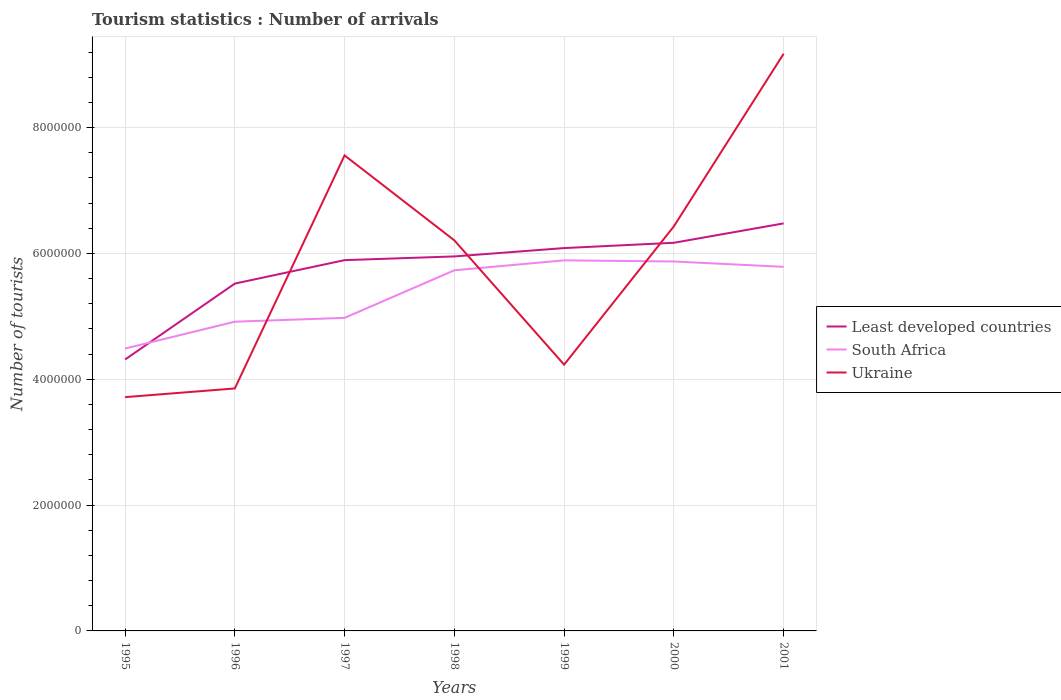How many different coloured lines are there?
Make the answer very short. 3. Is the number of lines equal to the number of legend labels?
Offer a very short reply. Yes. Across all years, what is the maximum number of tourist arrivals in South Africa?
Make the answer very short. 4.49e+06. In which year was the number of tourist arrivals in South Africa maximum?
Give a very brief answer. 1995. What is the total number of tourist arrivals in Ukraine in the graph?
Make the answer very short. 1.13e+06. What is the difference between the highest and the second highest number of tourist arrivals in South Africa?
Give a very brief answer. 1.40e+06. What is the difference between the highest and the lowest number of tourist arrivals in South Africa?
Offer a terse response. 4. How many lines are there?
Offer a terse response. 3. Are the values on the major ticks of Y-axis written in scientific E-notation?
Your answer should be compact. No. Does the graph contain grids?
Your response must be concise. Yes. How many legend labels are there?
Provide a short and direct response. 3. How are the legend labels stacked?
Your answer should be compact. Vertical. What is the title of the graph?
Your response must be concise. Tourism statistics : Number of arrivals. What is the label or title of the Y-axis?
Your answer should be very brief. Number of tourists. What is the Number of tourists in Least developed countries in 1995?
Ensure brevity in your answer.  4.31e+06. What is the Number of tourists in South Africa in 1995?
Your answer should be very brief. 4.49e+06. What is the Number of tourists in Ukraine in 1995?
Your response must be concise. 3.72e+06. What is the Number of tourists in Least developed countries in 1996?
Offer a terse response. 5.52e+06. What is the Number of tourists in South Africa in 1996?
Provide a short and direct response. 4.92e+06. What is the Number of tourists in Ukraine in 1996?
Offer a very short reply. 3.85e+06. What is the Number of tourists of Least developed countries in 1997?
Keep it short and to the point. 5.89e+06. What is the Number of tourists in South Africa in 1997?
Make the answer very short. 4.98e+06. What is the Number of tourists in Ukraine in 1997?
Your response must be concise. 7.56e+06. What is the Number of tourists of Least developed countries in 1998?
Your answer should be compact. 5.95e+06. What is the Number of tourists in South Africa in 1998?
Keep it short and to the point. 5.73e+06. What is the Number of tourists in Ukraine in 1998?
Keep it short and to the point. 6.21e+06. What is the Number of tourists of Least developed countries in 1999?
Provide a succinct answer. 6.09e+06. What is the Number of tourists in South Africa in 1999?
Make the answer very short. 5.89e+06. What is the Number of tourists in Ukraine in 1999?
Give a very brief answer. 4.23e+06. What is the Number of tourists in Least developed countries in 2000?
Provide a succinct answer. 6.17e+06. What is the Number of tourists of South Africa in 2000?
Keep it short and to the point. 5.87e+06. What is the Number of tourists of Ukraine in 2000?
Offer a terse response. 6.43e+06. What is the Number of tourists in Least developed countries in 2001?
Your response must be concise. 6.48e+06. What is the Number of tourists of South Africa in 2001?
Keep it short and to the point. 5.79e+06. What is the Number of tourists in Ukraine in 2001?
Offer a terse response. 9.17e+06. Across all years, what is the maximum Number of tourists of Least developed countries?
Ensure brevity in your answer.  6.48e+06. Across all years, what is the maximum Number of tourists of South Africa?
Provide a short and direct response. 5.89e+06. Across all years, what is the maximum Number of tourists in Ukraine?
Your response must be concise. 9.17e+06. Across all years, what is the minimum Number of tourists in Least developed countries?
Ensure brevity in your answer.  4.31e+06. Across all years, what is the minimum Number of tourists in South Africa?
Offer a terse response. 4.49e+06. Across all years, what is the minimum Number of tourists of Ukraine?
Keep it short and to the point. 3.72e+06. What is the total Number of tourists of Least developed countries in the graph?
Provide a succinct answer. 4.04e+07. What is the total Number of tourists of South Africa in the graph?
Your answer should be compact. 3.77e+07. What is the total Number of tourists of Ukraine in the graph?
Your answer should be very brief. 4.12e+07. What is the difference between the Number of tourists in Least developed countries in 1995 and that in 1996?
Your answer should be very brief. -1.21e+06. What is the difference between the Number of tourists of South Africa in 1995 and that in 1996?
Give a very brief answer. -4.27e+05. What is the difference between the Number of tourists in Ukraine in 1995 and that in 1996?
Provide a short and direct response. -1.38e+05. What is the difference between the Number of tourists in Least developed countries in 1995 and that in 1997?
Your response must be concise. -1.58e+06. What is the difference between the Number of tourists in South Africa in 1995 and that in 1997?
Offer a very short reply. -4.88e+05. What is the difference between the Number of tourists of Ukraine in 1995 and that in 1997?
Your answer should be very brief. -3.84e+06. What is the difference between the Number of tourists of Least developed countries in 1995 and that in 1998?
Make the answer very short. -1.64e+06. What is the difference between the Number of tourists in South Africa in 1995 and that in 1998?
Offer a terse response. -1.24e+06. What is the difference between the Number of tourists in Ukraine in 1995 and that in 1998?
Give a very brief answer. -2.49e+06. What is the difference between the Number of tourists in Least developed countries in 1995 and that in 1999?
Your response must be concise. -1.77e+06. What is the difference between the Number of tourists of South Africa in 1995 and that in 1999?
Make the answer very short. -1.40e+06. What is the difference between the Number of tourists in Ukraine in 1995 and that in 1999?
Ensure brevity in your answer.  -5.16e+05. What is the difference between the Number of tourists of Least developed countries in 1995 and that in 2000?
Offer a very short reply. -1.86e+06. What is the difference between the Number of tourists in South Africa in 1995 and that in 2000?
Your answer should be very brief. -1.38e+06. What is the difference between the Number of tourists in Ukraine in 1995 and that in 2000?
Make the answer very short. -2.72e+06. What is the difference between the Number of tourists in Least developed countries in 1995 and that in 2001?
Make the answer very short. -2.16e+06. What is the difference between the Number of tourists in South Africa in 1995 and that in 2001?
Ensure brevity in your answer.  -1.30e+06. What is the difference between the Number of tourists in Ukraine in 1995 and that in 2001?
Offer a terse response. -5.46e+06. What is the difference between the Number of tourists of Least developed countries in 1996 and that in 1997?
Your answer should be very brief. -3.73e+05. What is the difference between the Number of tourists of South Africa in 1996 and that in 1997?
Give a very brief answer. -6.10e+04. What is the difference between the Number of tourists in Ukraine in 1996 and that in 1997?
Your answer should be compact. -3.70e+06. What is the difference between the Number of tourists in Least developed countries in 1996 and that in 1998?
Provide a succinct answer. -4.32e+05. What is the difference between the Number of tourists of South Africa in 1996 and that in 1998?
Offer a terse response. -8.17e+05. What is the difference between the Number of tourists of Ukraine in 1996 and that in 1998?
Make the answer very short. -2.35e+06. What is the difference between the Number of tourists in Least developed countries in 1996 and that in 1999?
Make the answer very short. -5.65e+05. What is the difference between the Number of tourists in South Africa in 1996 and that in 1999?
Keep it short and to the point. -9.75e+05. What is the difference between the Number of tourists of Ukraine in 1996 and that in 1999?
Your answer should be very brief. -3.78e+05. What is the difference between the Number of tourists in Least developed countries in 1996 and that in 2000?
Your answer should be very brief. -6.49e+05. What is the difference between the Number of tourists in South Africa in 1996 and that in 2000?
Offer a terse response. -9.57e+05. What is the difference between the Number of tourists of Ukraine in 1996 and that in 2000?
Your answer should be very brief. -2.58e+06. What is the difference between the Number of tourists in Least developed countries in 1996 and that in 2001?
Make the answer very short. -9.57e+05. What is the difference between the Number of tourists in South Africa in 1996 and that in 2001?
Your answer should be compact. -8.72e+05. What is the difference between the Number of tourists in Ukraine in 1996 and that in 2001?
Offer a very short reply. -5.32e+06. What is the difference between the Number of tourists in Least developed countries in 1997 and that in 1998?
Ensure brevity in your answer.  -5.89e+04. What is the difference between the Number of tourists of South Africa in 1997 and that in 1998?
Offer a terse response. -7.56e+05. What is the difference between the Number of tourists in Ukraine in 1997 and that in 1998?
Provide a short and direct response. 1.35e+06. What is the difference between the Number of tourists of Least developed countries in 1997 and that in 1999?
Provide a short and direct response. -1.92e+05. What is the difference between the Number of tourists in South Africa in 1997 and that in 1999?
Keep it short and to the point. -9.14e+05. What is the difference between the Number of tourists of Ukraine in 1997 and that in 1999?
Offer a very short reply. 3.33e+06. What is the difference between the Number of tourists in Least developed countries in 1997 and that in 2000?
Keep it short and to the point. -2.76e+05. What is the difference between the Number of tourists in South Africa in 1997 and that in 2000?
Provide a short and direct response. -8.96e+05. What is the difference between the Number of tourists of Ukraine in 1997 and that in 2000?
Offer a terse response. 1.13e+06. What is the difference between the Number of tourists in Least developed countries in 1997 and that in 2001?
Make the answer very short. -5.84e+05. What is the difference between the Number of tourists of South Africa in 1997 and that in 2001?
Make the answer very short. -8.11e+05. What is the difference between the Number of tourists of Ukraine in 1997 and that in 2001?
Your answer should be compact. -1.62e+06. What is the difference between the Number of tourists of Least developed countries in 1998 and that in 1999?
Offer a terse response. -1.33e+05. What is the difference between the Number of tourists in South Africa in 1998 and that in 1999?
Your response must be concise. -1.58e+05. What is the difference between the Number of tourists of Ukraine in 1998 and that in 1999?
Offer a terse response. 1.98e+06. What is the difference between the Number of tourists in Least developed countries in 1998 and that in 2000?
Keep it short and to the point. -2.17e+05. What is the difference between the Number of tourists of Ukraine in 1998 and that in 2000?
Your answer should be compact. -2.23e+05. What is the difference between the Number of tourists in Least developed countries in 1998 and that in 2001?
Provide a short and direct response. -5.25e+05. What is the difference between the Number of tourists of South Africa in 1998 and that in 2001?
Provide a short and direct response. -5.50e+04. What is the difference between the Number of tourists in Ukraine in 1998 and that in 2001?
Give a very brief answer. -2.97e+06. What is the difference between the Number of tourists in Least developed countries in 1999 and that in 2000?
Your response must be concise. -8.42e+04. What is the difference between the Number of tourists of South Africa in 1999 and that in 2000?
Ensure brevity in your answer.  1.80e+04. What is the difference between the Number of tourists of Ukraine in 1999 and that in 2000?
Provide a short and direct response. -2.20e+06. What is the difference between the Number of tourists in Least developed countries in 1999 and that in 2001?
Offer a very short reply. -3.93e+05. What is the difference between the Number of tourists in South Africa in 1999 and that in 2001?
Offer a very short reply. 1.03e+05. What is the difference between the Number of tourists of Ukraine in 1999 and that in 2001?
Offer a terse response. -4.94e+06. What is the difference between the Number of tourists in Least developed countries in 2000 and that in 2001?
Offer a very short reply. -3.08e+05. What is the difference between the Number of tourists in South Africa in 2000 and that in 2001?
Ensure brevity in your answer.  8.50e+04. What is the difference between the Number of tourists in Ukraine in 2000 and that in 2001?
Give a very brief answer. -2.74e+06. What is the difference between the Number of tourists of Least developed countries in 1995 and the Number of tourists of South Africa in 1996?
Your response must be concise. -6.01e+05. What is the difference between the Number of tourists of Least developed countries in 1995 and the Number of tourists of Ukraine in 1996?
Offer a terse response. 4.60e+05. What is the difference between the Number of tourists in South Africa in 1995 and the Number of tourists in Ukraine in 1996?
Offer a terse response. 6.34e+05. What is the difference between the Number of tourists in Least developed countries in 1995 and the Number of tourists in South Africa in 1997?
Keep it short and to the point. -6.62e+05. What is the difference between the Number of tourists in Least developed countries in 1995 and the Number of tourists in Ukraine in 1997?
Your response must be concise. -3.24e+06. What is the difference between the Number of tourists of South Africa in 1995 and the Number of tourists of Ukraine in 1997?
Make the answer very short. -3.07e+06. What is the difference between the Number of tourists of Least developed countries in 1995 and the Number of tourists of South Africa in 1998?
Make the answer very short. -1.42e+06. What is the difference between the Number of tourists of Least developed countries in 1995 and the Number of tourists of Ukraine in 1998?
Ensure brevity in your answer.  -1.89e+06. What is the difference between the Number of tourists of South Africa in 1995 and the Number of tourists of Ukraine in 1998?
Make the answer very short. -1.72e+06. What is the difference between the Number of tourists in Least developed countries in 1995 and the Number of tourists in South Africa in 1999?
Provide a succinct answer. -1.58e+06. What is the difference between the Number of tourists of Least developed countries in 1995 and the Number of tourists of Ukraine in 1999?
Make the answer very short. 8.17e+04. What is the difference between the Number of tourists of South Africa in 1995 and the Number of tourists of Ukraine in 1999?
Provide a short and direct response. 2.56e+05. What is the difference between the Number of tourists in Least developed countries in 1995 and the Number of tourists in South Africa in 2000?
Your response must be concise. -1.56e+06. What is the difference between the Number of tourists in Least developed countries in 1995 and the Number of tourists in Ukraine in 2000?
Provide a short and direct response. -2.12e+06. What is the difference between the Number of tourists in South Africa in 1995 and the Number of tourists in Ukraine in 2000?
Provide a short and direct response. -1.94e+06. What is the difference between the Number of tourists in Least developed countries in 1995 and the Number of tourists in South Africa in 2001?
Offer a terse response. -1.47e+06. What is the difference between the Number of tourists of Least developed countries in 1995 and the Number of tourists of Ukraine in 2001?
Provide a short and direct response. -4.86e+06. What is the difference between the Number of tourists in South Africa in 1995 and the Number of tourists in Ukraine in 2001?
Provide a succinct answer. -4.69e+06. What is the difference between the Number of tourists of Least developed countries in 1996 and the Number of tourists of South Africa in 1997?
Your answer should be very brief. 5.44e+05. What is the difference between the Number of tourists of Least developed countries in 1996 and the Number of tourists of Ukraine in 1997?
Your answer should be compact. -2.04e+06. What is the difference between the Number of tourists in South Africa in 1996 and the Number of tourists in Ukraine in 1997?
Give a very brief answer. -2.64e+06. What is the difference between the Number of tourists in Least developed countries in 1996 and the Number of tourists in South Africa in 1998?
Keep it short and to the point. -2.12e+05. What is the difference between the Number of tourists of Least developed countries in 1996 and the Number of tourists of Ukraine in 1998?
Provide a succinct answer. -6.88e+05. What is the difference between the Number of tourists in South Africa in 1996 and the Number of tourists in Ukraine in 1998?
Keep it short and to the point. -1.29e+06. What is the difference between the Number of tourists of Least developed countries in 1996 and the Number of tourists of South Africa in 1999?
Your answer should be very brief. -3.70e+05. What is the difference between the Number of tourists of Least developed countries in 1996 and the Number of tourists of Ukraine in 1999?
Offer a terse response. 1.29e+06. What is the difference between the Number of tourists in South Africa in 1996 and the Number of tourists in Ukraine in 1999?
Ensure brevity in your answer.  6.83e+05. What is the difference between the Number of tourists in Least developed countries in 1996 and the Number of tourists in South Africa in 2000?
Your answer should be very brief. -3.52e+05. What is the difference between the Number of tourists of Least developed countries in 1996 and the Number of tourists of Ukraine in 2000?
Your response must be concise. -9.11e+05. What is the difference between the Number of tourists in South Africa in 1996 and the Number of tourists in Ukraine in 2000?
Your answer should be compact. -1.52e+06. What is the difference between the Number of tourists of Least developed countries in 1996 and the Number of tourists of South Africa in 2001?
Provide a succinct answer. -2.67e+05. What is the difference between the Number of tourists of Least developed countries in 1996 and the Number of tourists of Ukraine in 2001?
Keep it short and to the point. -3.65e+06. What is the difference between the Number of tourists in South Africa in 1996 and the Number of tourists in Ukraine in 2001?
Provide a succinct answer. -4.26e+06. What is the difference between the Number of tourists of Least developed countries in 1997 and the Number of tourists of South Africa in 1998?
Provide a short and direct response. 1.61e+05. What is the difference between the Number of tourists of Least developed countries in 1997 and the Number of tourists of Ukraine in 1998?
Make the answer very short. -3.15e+05. What is the difference between the Number of tourists of South Africa in 1997 and the Number of tourists of Ukraine in 1998?
Keep it short and to the point. -1.23e+06. What is the difference between the Number of tourists of Least developed countries in 1997 and the Number of tourists of South Africa in 1999?
Ensure brevity in your answer.  3483.7. What is the difference between the Number of tourists of Least developed countries in 1997 and the Number of tourists of Ukraine in 1999?
Provide a succinct answer. 1.66e+06. What is the difference between the Number of tourists in South Africa in 1997 and the Number of tourists in Ukraine in 1999?
Make the answer very short. 7.44e+05. What is the difference between the Number of tourists in Least developed countries in 1997 and the Number of tourists in South Africa in 2000?
Offer a very short reply. 2.15e+04. What is the difference between the Number of tourists in Least developed countries in 1997 and the Number of tourists in Ukraine in 2000?
Offer a terse response. -5.38e+05. What is the difference between the Number of tourists of South Africa in 1997 and the Number of tourists of Ukraine in 2000?
Keep it short and to the point. -1.46e+06. What is the difference between the Number of tourists of Least developed countries in 1997 and the Number of tourists of South Africa in 2001?
Make the answer very short. 1.06e+05. What is the difference between the Number of tourists of Least developed countries in 1997 and the Number of tourists of Ukraine in 2001?
Offer a very short reply. -3.28e+06. What is the difference between the Number of tourists in South Africa in 1997 and the Number of tourists in Ukraine in 2001?
Provide a short and direct response. -4.20e+06. What is the difference between the Number of tourists of Least developed countries in 1998 and the Number of tourists of South Africa in 1999?
Offer a very short reply. 6.24e+04. What is the difference between the Number of tourists of Least developed countries in 1998 and the Number of tourists of Ukraine in 1999?
Provide a short and direct response. 1.72e+06. What is the difference between the Number of tourists in South Africa in 1998 and the Number of tourists in Ukraine in 1999?
Provide a succinct answer. 1.50e+06. What is the difference between the Number of tourists in Least developed countries in 1998 and the Number of tourists in South Africa in 2000?
Provide a short and direct response. 8.04e+04. What is the difference between the Number of tourists in Least developed countries in 1998 and the Number of tourists in Ukraine in 2000?
Ensure brevity in your answer.  -4.79e+05. What is the difference between the Number of tourists in South Africa in 1998 and the Number of tourists in Ukraine in 2000?
Provide a short and direct response. -6.99e+05. What is the difference between the Number of tourists of Least developed countries in 1998 and the Number of tourists of South Africa in 2001?
Give a very brief answer. 1.65e+05. What is the difference between the Number of tourists of Least developed countries in 1998 and the Number of tourists of Ukraine in 2001?
Your answer should be compact. -3.22e+06. What is the difference between the Number of tourists in South Africa in 1998 and the Number of tourists in Ukraine in 2001?
Your response must be concise. -3.44e+06. What is the difference between the Number of tourists in Least developed countries in 1999 and the Number of tourists in South Africa in 2000?
Your answer should be very brief. 2.13e+05. What is the difference between the Number of tourists of Least developed countries in 1999 and the Number of tourists of Ukraine in 2000?
Your answer should be very brief. -3.46e+05. What is the difference between the Number of tourists in South Africa in 1999 and the Number of tourists in Ukraine in 2000?
Provide a short and direct response. -5.41e+05. What is the difference between the Number of tourists in Least developed countries in 1999 and the Number of tourists in South Africa in 2001?
Your answer should be compact. 2.98e+05. What is the difference between the Number of tourists of Least developed countries in 1999 and the Number of tourists of Ukraine in 2001?
Your answer should be compact. -3.09e+06. What is the difference between the Number of tourists of South Africa in 1999 and the Number of tourists of Ukraine in 2001?
Your answer should be compact. -3.28e+06. What is the difference between the Number of tourists in Least developed countries in 2000 and the Number of tourists in South Africa in 2001?
Your response must be concise. 3.82e+05. What is the difference between the Number of tourists of Least developed countries in 2000 and the Number of tourists of Ukraine in 2001?
Your response must be concise. -3.00e+06. What is the difference between the Number of tourists of South Africa in 2000 and the Number of tourists of Ukraine in 2001?
Your answer should be compact. -3.30e+06. What is the average Number of tourists in Least developed countries per year?
Make the answer very short. 5.77e+06. What is the average Number of tourists in South Africa per year?
Provide a succinct answer. 5.38e+06. What is the average Number of tourists of Ukraine per year?
Your response must be concise. 5.88e+06. In the year 1995, what is the difference between the Number of tourists in Least developed countries and Number of tourists in South Africa?
Your answer should be very brief. -1.74e+05. In the year 1995, what is the difference between the Number of tourists of Least developed countries and Number of tourists of Ukraine?
Keep it short and to the point. 5.98e+05. In the year 1995, what is the difference between the Number of tourists of South Africa and Number of tourists of Ukraine?
Your answer should be very brief. 7.72e+05. In the year 1996, what is the difference between the Number of tourists of Least developed countries and Number of tourists of South Africa?
Your answer should be very brief. 6.05e+05. In the year 1996, what is the difference between the Number of tourists of Least developed countries and Number of tourists of Ukraine?
Your answer should be very brief. 1.67e+06. In the year 1996, what is the difference between the Number of tourists of South Africa and Number of tourists of Ukraine?
Give a very brief answer. 1.06e+06. In the year 1997, what is the difference between the Number of tourists of Least developed countries and Number of tourists of South Africa?
Provide a short and direct response. 9.17e+05. In the year 1997, what is the difference between the Number of tourists in Least developed countries and Number of tourists in Ukraine?
Offer a very short reply. -1.66e+06. In the year 1997, what is the difference between the Number of tourists in South Africa and Number of tourists in Ukraine?
Your response must be concise. -2.58e+06. In the year 1998, what is the difference between the Number of tourists in Least developed countries and Number of tourists in South Africa?
Keep it short and to the point. 2.20e+05. In the year 1998, what is the difference between the Number of tourists of Least developed countries and Number of tourists of Ukraine?
Provide a succinct answer. -2.56e+05. In the year 1998, what is the difference between the Number of tourists of South Africa and Number of tourists of Ukraine?
Your answer should be compact. -4.76e+05. In the year 1999, what is the difference between the Number of tourists in Least developed countries and Number of tourists in South Africa?
Give a very brief answer. 1.95e+05. In the year 1999, what is the difference between the Number of tourists in Least developed countries and Number of tourists in Ukraine?
Keep it short and to the point. 1.85e+06. In the year 1999, what is the difference between the Number of tourists in South Africa and Number of tourists in Ukraine?
Your answer should be very brief. 1.66e+06. In the year 2000, what is the difference between the Number of tourists of Least developed countries and Number of tourists of South Africa?
Provide a succinct answer. 2.97e+05. In the year 2000, what is the difference between the Number of tourists of Least developed countries and Number of tourists of Ukraine?
Ensure brevity in your answer.  -2.62e+05. In the year 2000, what is the difference between the Number of tourists in South Africa and Number of tourists in Ukraine?
Make the answer very short. -5.59e+05. In the year 2001, what is the difference between the Number of tourists of Least developed countries and Number of tourists of South Africa?
Make the answer very short. 6.91e+05. In the year 2001, what is the difference between the Number of tourists in Least developed countries and Number of tourists in Ukraine?
Provide a short and direct response. -2.70e+06. In the year 2001, what is the difference between the Number of tourists of South Africa and Number of tourists of Ukraine?
Provide a succinct answer. -3.39e+06. What is the ratio of the Number of tourists of Least developed countries in 1995 to that in 1996?
Keep it short and to the point. 0.78. What is the ratio of the Number of tourists in South Africa in 1995 to that in 1996?
Ensure brevity in your answer.  0.91. What is the ratio of the Number of tourists of Ukraine in 1995 to that in 1996?
Give a very brief answer. 0.96. What is the ratio of the Number of tourists of Least developed countries in 1995 to that in 1997?
Ensure brevity in your answer.  0.73. What is the ratio of the Number of tourists of South Africa in 1995 to that in 1997?
Keep it short and to the point. 0.9. What is the ratio of the Number of tourists of Ukraine in 1995 to that in 1997?
Your answer should be compact. 0.49. What is the ratio of the Number of tourists of Least developed countries in 1995 to that in 1998?
Provide a succinct answer. 0.72. What is the ratio of the Number of tourists of South Africa in 1995 to that in 1998?
Give a very brief answer. 0.78. What is the ratio of the Number of tourists in Ukraine in 1995 to that in 1998?
Keep it short and to the point. 0.6. What is the ratio of the Number of tourists in Least developed countries in 1995 to that in 1999?
Your answer should be compact. 0.71. What is the ratio of the Number of tourists in South Africa in 1995 to that in 1999?
Keep it short and to the point. 0.76. What is the ratio of the Number of tourists in Ukraine in 1995 to that in 1999?
Your response must be concise. 0.88. What is the ratio of the Number of tourists of Least developed countries in 1995 to that in 2000?
Offer a terse response. 0.7. What is the ratio of the Number of tourists of South Africa in 1995 to that in 2000?
Offer a terse response. 0.76. What is the ratio of the Number of tourists in Ukraine in 1995 to that in 2000?
Give a very brief answer. 0.58. What is the ratio of the Number of tourists of Least developed countries in 1995 to that in 2001?
Your response must be concise. 0.67. What is the ratio of the Number of tourists in South Africa in 1995 to that in 2001?
Provide a succinct answer. 0.78. What is the ratio of the Number of tourists in Ukraine in 1995 to that in 2001?
Keep it short and to the point. 0.41. What is the ratio of the Number of tourists of Least developed countries in 1996 to that in 1997?
Provide a short and direct response. 0.94. What is the ratio of the Number of tourists of South Africa in 1996 to that in 1997?
Provide a short and direct response. 0.99. What is the ratio of the Number of tourists in Ukraine in 1996 to that in 1997?
Offer a very short reply. 0.51. What is the ratio of the Number of tourists in Least developed countries in 1996 to that in 1998?
Make the answer very short. 0.93. What is the ratio of the Number of tourists of South Africa in 1996 to that in 1998?
Provide a succinct answer. 0.86. What is the ratio of the Number of tourists in Ukraine in 1996 to that in 1998?
Give a very brief answer. 0.62. What is the ratio of the Number of tourists in Least developed countries in 1996 to that in 1999?
Your response must be concise. 0.91. What is the ratio of the Number of tourists in South Africa in 1996 to that in 1999?
Provide a succinct answer. 0.83. What is the ratio of the Number of tourists in Ukraine in 1996 to that in 1999?
Your response must be concise. 0.91. What is the ratio of the Number of tourists of Least developed countries in 1996 to that in 2000?
Your response must be concise. 0.89. What is the ratio of the Number of tourists of South Africa in 1996 to that in 2000?
Your response must be concise. 0.84. What is the ratio of the Number of tourists of Ukraine in 1996 to that in 2000?
Make the answer very short. 0.6. What is the ratio of the Number of tourists in Least developed countries in 1996 to that in 2001?
Your response must be concise. 0.85. What is the ratio of the Number of tourists of South Africa in 1996 to that in 2001?
Offer a terse response. 0.85. What is the ratio of the Number of tourists of Ukraine in 1996 to that in 2001?
Your answer should be very brief. 0.42. What is the ratio of the Number of tourists in South Africa in 1997 to that in 1998?
Provide a succinct answer. 0.87. What is the ratio of the Number of tourists in Ukraine in 1997 to that in 1998?
Your response must be concise. 1.22. What is the ratio of the Number of tourists of Least developed countries in 1997 to that in 1999?
Ensure brevity in your answer.  0.97. What is the ratio of the Number of tourists in South Africa in 1997 to that in 1999?
Keep it short and to the point. 0.84. What is the ratio of the Number of tourists of Ukraine in 1997 to that in 1999?
Ensure brevity in your answer.  1.79. What is the ratio of the Number of tourists of Least developed countries in 1997 to that in 2000?
Make the answer very short. 0.96. What is the ratio of the Number of tourists of South Africa in 1997 to that in 2000?
Your answer should be compact. 0.85. What is the ratio of the Number of tourists in Ukraine in 1997 to that in 2000?
Ensure brevity in your answer.  1.18. What is the ratio of the Number of tourists of Least developed countries in 1997 to that in 2001?
Offer a very short reply. 0.91. What is the ratio of the Number of tourists of South Africa in 1997 to that in 2001?
Your answer should be compact. 0.86. What is the ratio of the Number of tourists of Ukraine in 1997 to that in 2001?
Your response must be concise. 0.82. What is the ratio of the Number of tourists of Least developed countries in 1998 to that in 1999?
Your answer should be very brief. 0.98. What is the ratio of the Number of tourists of South Africa in 1998 to that in 1999?
Offer a very short reply. 0.97. What is the ratio of the Number of tourists of Ukraine in 1998 to that in 1999?
Your answer should be compact. 1.47. What is the ratio of the Number of tourists of Least developed countries in 1998 to that in 2000?
Keep it short and to the point. 0.96. What is the ratio of the Number of tourists of South Africa in 1998 to that in 2000?
Make the answer very short. 0.98. What is the ratio of the Number of tourists in Ukraine in 1998 to that in 2000?
Provide a short and direct response. 0.97. What is the ratio of the Number of tourists of Least developed countries in 1998 to that in 2001?
Make the answer very short. 0.92. What is the ratio of the Number of tourists of South Africa in 1998 to that in 2001?
Your response must be concise. 0.99. What is the ratio of the Number of tourists in Ukraine in 1998 to that in 2001?
Give a very brief answer. 0.68. What is the ratio of the Number of tourists in Least developed countries in 1999 to that in 2000?
Ensure brevity in your answer.  0.99. What is the ratio of the Number of tourists in South Africa in 1999 to that in 2000?
Make the answer very short. 1. What is the ratio of the Number of tourists of Ukraine in 1999 to that in 2000?
Provide a succinct answer. 0.66. What is the ratio of the Number of tourists in Least developed countries in 1999 to that in 2001?
Provide a short and direct response. 0.94. What is the ratio of the Number of tourists in South Africa in 1999 to that in 2001?
Provide a succinct answer. 1.02. What is the ratio of the Number of tourists in Ukraine in 1999 to that in 2001?
Make the answer very short. 0.46. What is the ratio of the Number of tourists of Least developed countries in 2000 to that in 2001?
Make the answer very short. 0.95. What is the ratio of the Number of tourists of South Africa in 2000 to that in 2001?
Ensure brevity in your answer.  1.01. What is the ratio of the Number of tourists of Ukraine in 2000 to that in 2001?
Make the answer very short. 0.7. What is the difference between the highest and the second highest Number of tourists of Least developed countries?
Provide a short and direct response. 3.08e+05. What is the difference between the highest and the second highest Number of tourists of South Africa?
Provide a short and direct response. 1.80e+04. What is the difference between the highest and the second highest Number of tourists of Ukraine?
Give a very brief answer. 1.62e+06. What is the difference between the highest and the lowest Number of tourists of Least developed countries?
Your response must be concise. 2.16e+06. What is the difference between the highest and the lowest Number of tourists of South Africa?
Provide a short and direct response. 1.40e+06. What is the difference between the highest and the lowest Number of tourists of Ukraine?
Provide a short and direct response. 5.46e+06. 